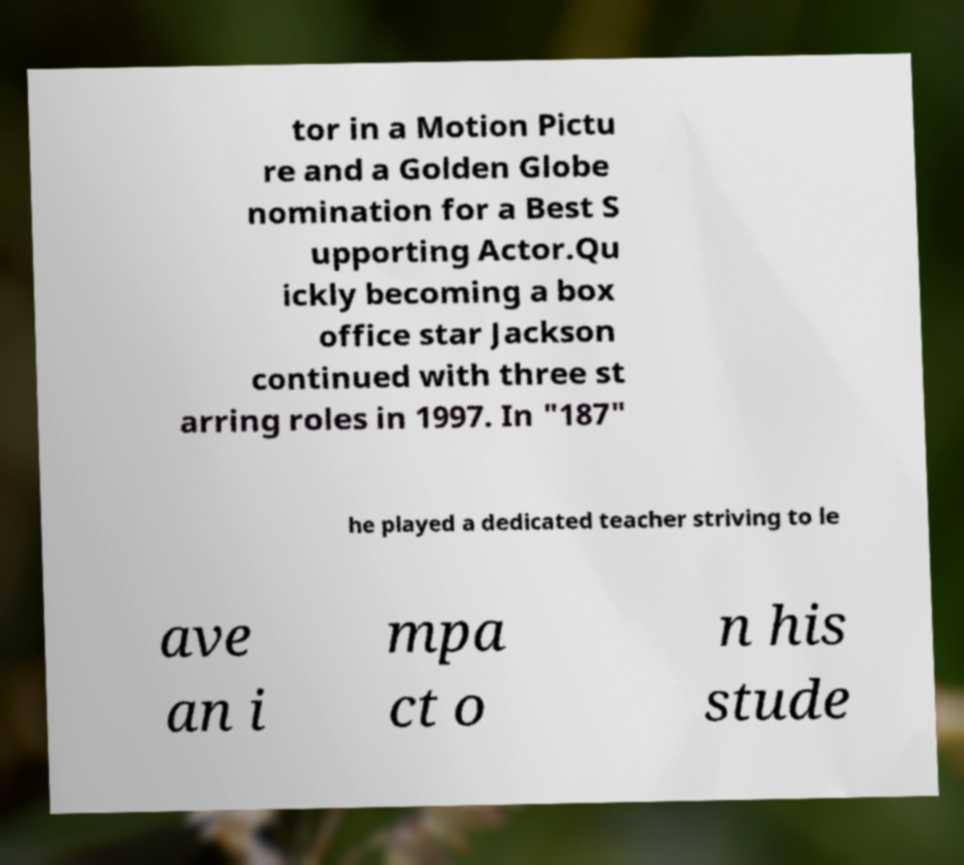Could you assist in decoding the text presented in this image and type it out clearly? tor in a Motion Pictu re and a Golden Globe nomination for a Best S upporting Actor.Qu ickly becoming a box office star Jackson continued with three st arring roles in 1997. In "187" he played a dedicated teacher striving to le ave an i mpa ct o n his stude 